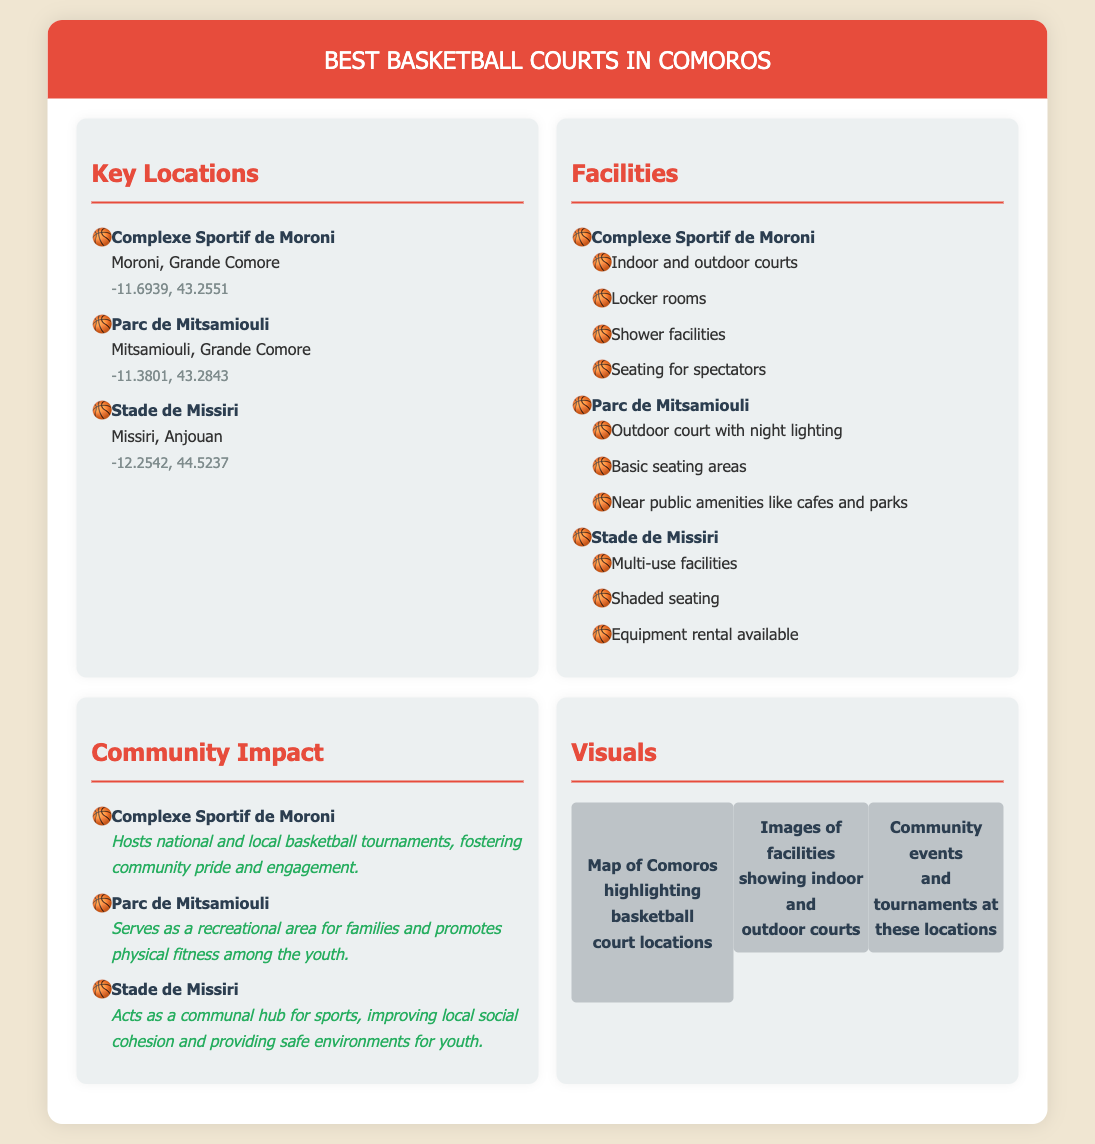What is the first basketball court listed? The first basketball court mentioned in the document is the Complexe Sportif de Moroni.
Answer: Complexe Sportif de Moroni Which location has indoor and outdoor courts? The Complexe Sportif de Moroni offers both indoor and outdoor courts as per the document.
Answer: Complexe Sportif de Moroni What is one facility available at Stade de Missiri? The document states that Stade de Missiri has shaded seating among its facilities.
Answer: Shaded seating Which basketball court hosts national and local tournaments? The Complexe Sportif de Moroni is indicated to host national and local tournaments, enhancing community involvement.
Answer: Complexe Sportif de Moroni How many key locations are mentioned in the document? The document lists three key locations for basketball courts in Comoros.
Answer: 3 What does Parc de Mitsamiouli promote among the youth? The document states that Parc de Mitsamiouli promotes physical fitness among the youth.
Answer: Physical fitness What distinguishes the Parc de Mitsamiouli from others? The outdoor court features night lighting, which distinguishes it from other locations.
Answer: Night lighting Which location serves as a communal hub for sports? Stade de Missiri is identified in the document as a communal hub for sports.
Answer: Stade de Missiri 